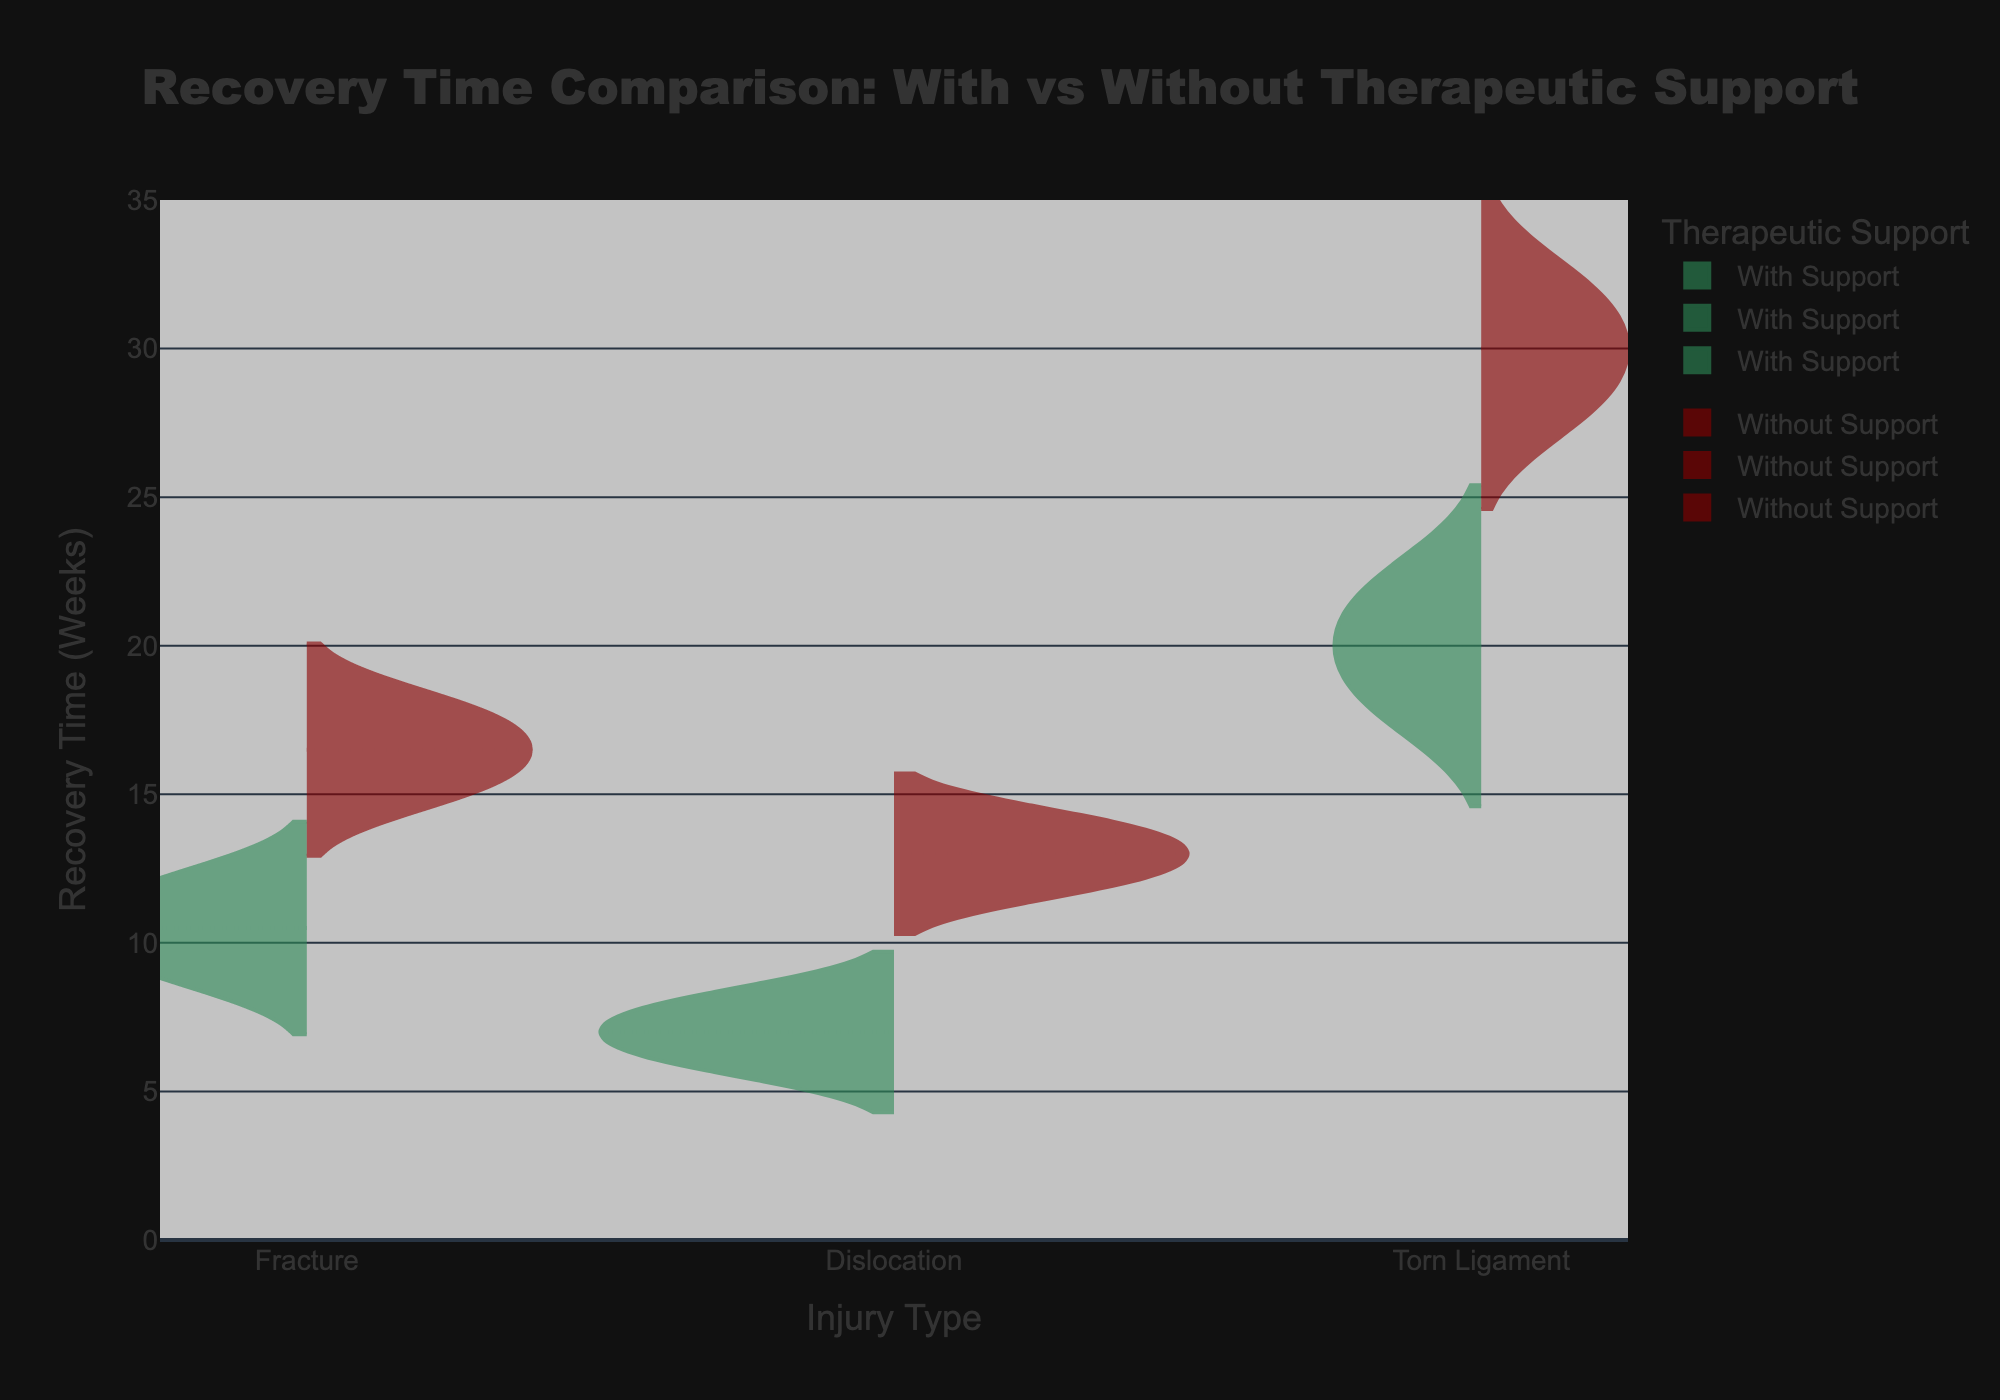What's the title of the figure? The title of the figure is displayed at the top of the plot. It reads "Recovery Time Comparison: With vs Without Therapeutic Support"
Answer: Recovery Time Comparison: With vs Without Therapeutic Support What are the different types of injuries shown in the figure? The types of injuries are identified along the x-axis of the plot. They are Fracture, Dislocation, and Torn Ligament.
Answer: Fracture, Dislocation, Torn Ligament What is the range of recovery times shown on the y-axis? The y-axis is labeled "Recovery Time (Weeks)" and ranges from 0 to 35 weeks. This is evident from the graph's y-axis labels and ticks.
Answer: 0 to 35 weeks Which injury type shows the largest difference in average recovery time between those with and without therapeutic support? By examining the mean lines (usually indicated by a thicker line or different color) within each injury category, we can compare the average recovery times for the two groups. For Torn Ligament, the difference is most noticeable.
Answer: Torn Ligament For Fracture injuries, which group has a lower average recovery time? Looking at the mean lines within the Fracture injury violins, the group 'With Support' (left side) has a lower average recovery time than the group 'Without Support' (right side).
Answer: With Support Which group generally has more outliers, those with or without therapeutic support? Outliers are indicated by the points outside the Violin plot. By comparing the two sides of the violins, the group 'Without Support' tends to have more outliers in most injury categories.
Answer: Without Support On average, how much shorter is the recovery time for Dislocation injuries with therapeutic support compared to without? The average recovery time difference can be estimated by subtracting the average recovery time (mean line) for the 'With Support' group from that of the 'Without Support' group for Dislocation injuries. It appears to be around 6 weeks.
Answer: About 6 weeks What color is used to represent the data for "With Support"? The plot uses two colors for the data. The color for "With Support" is a shade of green.
Answer: Green What is the maximum recovery time observed for Torn Ligament injuries without therapeutic support? The highest point on the 'Without Support' side of the Torn Ligament violin plot represents the maximum recovery time, which is 32 weeks.
Answer: 32 weeks Which injury type with therapeutic support has the shortest recovery time? By examining the lowest points on the 'With Support' side for each injury type, Dislocation injuries have the shortest recovery time at 6 weeks.
Answer: Dislocation 